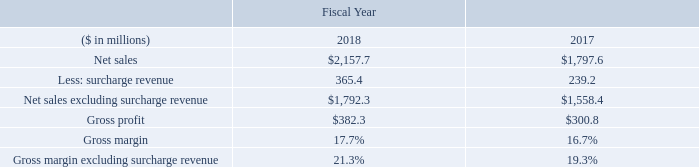Gross Profit
Gross profit in fiscal year 2018 increased to $382.3 million, or 17.7 percent of net sales from $300.8 million, or 16.7 percent of net sales for fiscal year 2017. Excluding the impact of the surcharge revenue, our gross margin in fiscal year 2018 was 21.3 percent compared to 19.3 percent in fiscal year 2017. The results reflect the impact of stronger demand and improved product mix coupled with operating cost improvements compared to fiscal year 2017.
Our surcharge mechanism is structured to recover increases in raw material costs, although in certain cases with a lag effect as discussed above. While the surcharge generally protects the absolute gross profit dollars, it does have a dilutive effect on gross margin as a percent of sales. The following represents a summary of the dilutive impact of the surcharge on gross margin. We present and discuss these financial measures because management believes removing the impact of surcharge provides a more consistent and meaningful basis for comparing results of operations from period to period. See the section “Non-GAAP Financial Measures” below for further discussion of these financial measures.
What was the gross profit in 2018? $382.3 million. What was the gross profit in 2017 as a percentage of net sales? 16.7 percent. In which years was gross profit calculated? 2018, 2017. In which year was the Gross margin excluding surcharge revenue larger? 21.3%>19.3%
Answer: 2018. What was the change in gross profit in 2018 from 2017?
Answer scale should be: million. 382.3-300.8
Answer: 81.5. What was the percentage change in gross profit in 2018 from 2017?
Answer scale should be: percent. (382.3-300.8)/300.8
Answer: 27.09. 